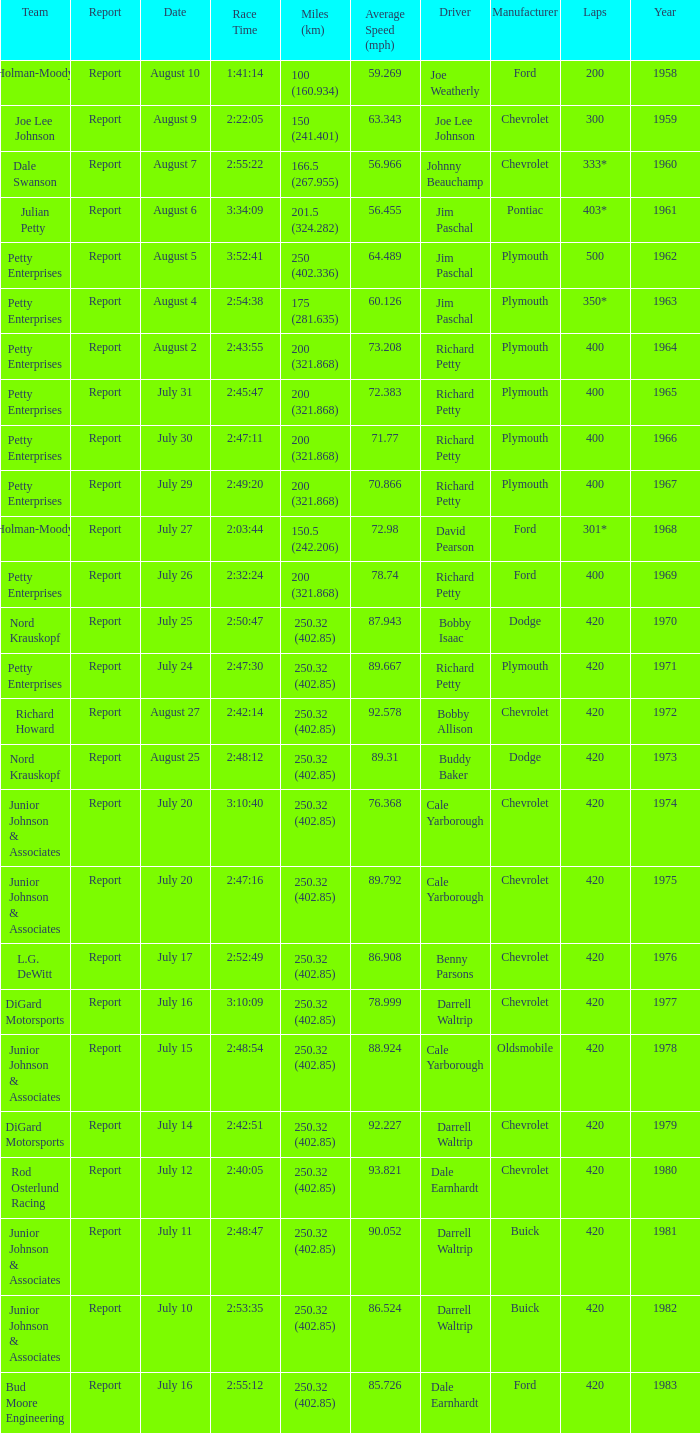What date was the race in 1968 run on? July 27. 